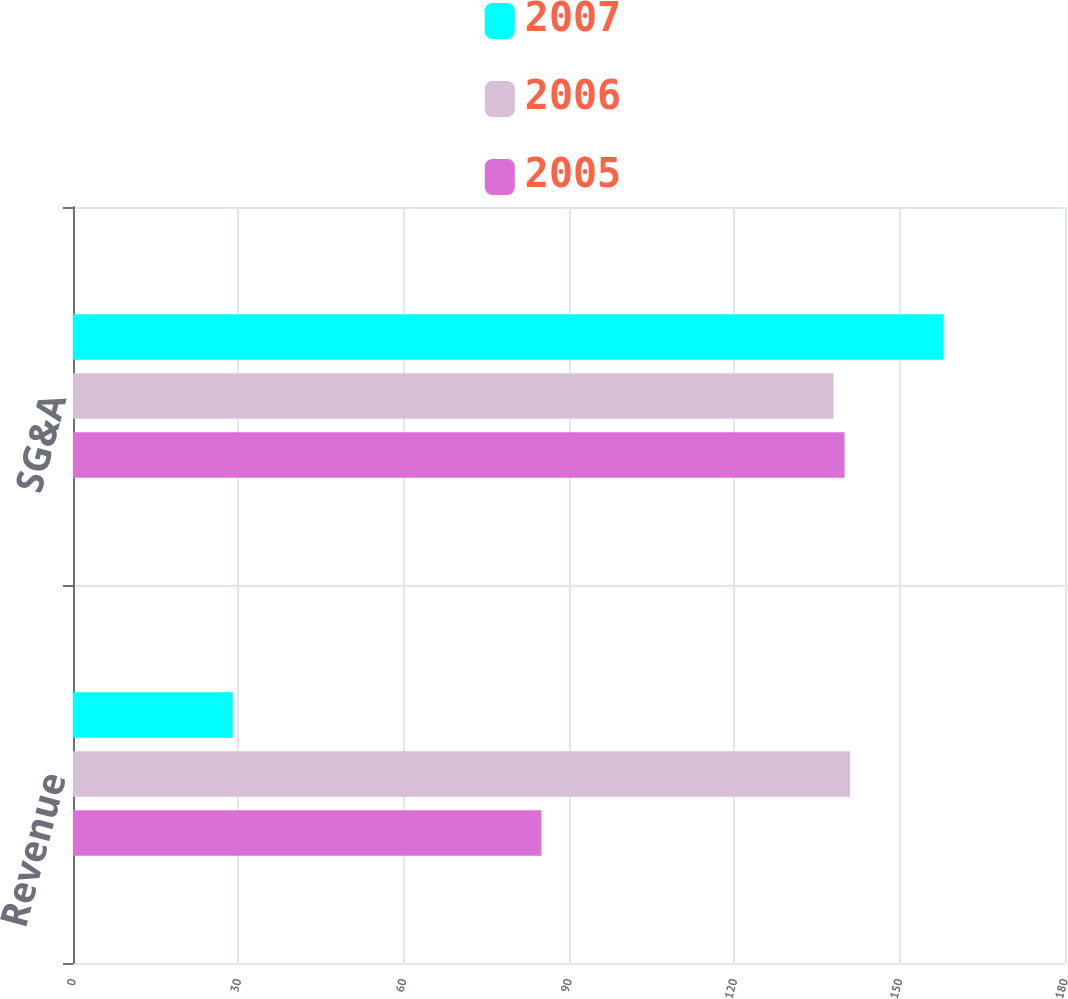<chart> <loc_0><loc_0><loc_500><loc_500><stacked_bar_chart><ecel><fcel>Revenue<fcel>SG&A<nl><fcel>2007<fcel>29<fcel>158<nl><fcel>2006<fcel>141<fcel>138<nl><fcel>2005<fcel>85<fcel>140<nl></chart> 